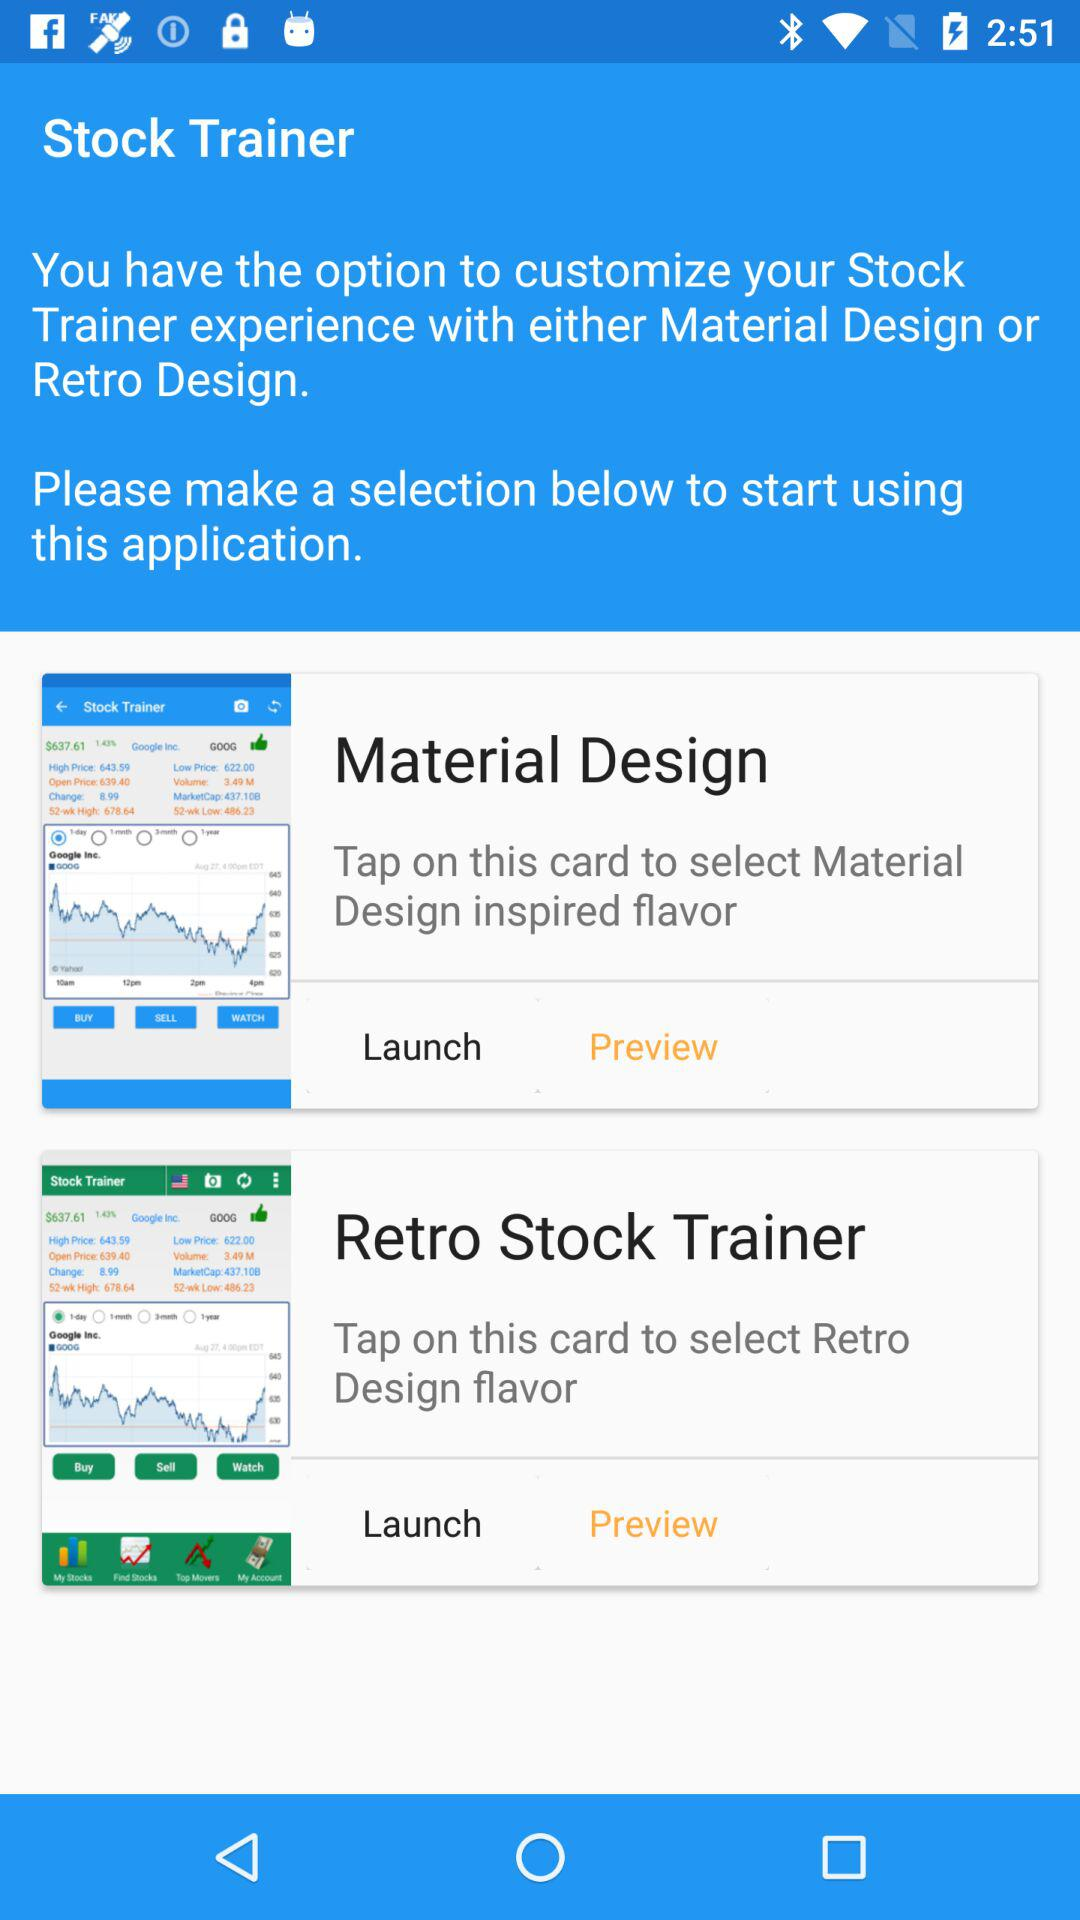What option can we select to start the application? You can select the options "Material Design" and "Retro Stock Trainer" to start the application. 